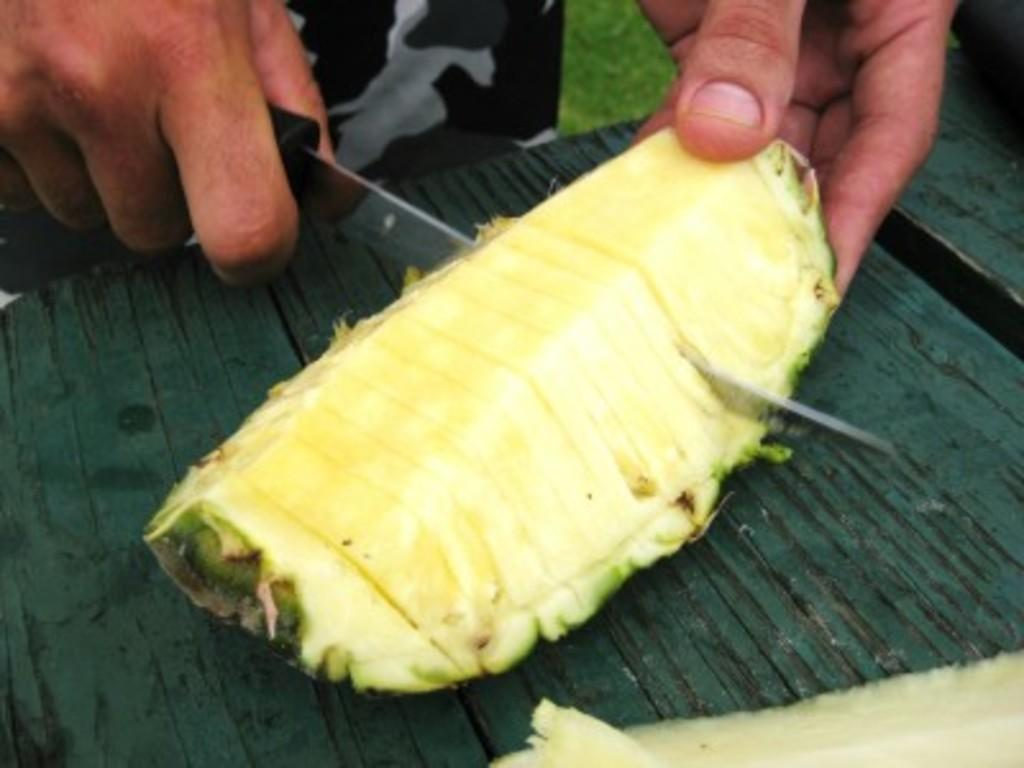What is the person in the image doing? The person is cutting a pineapple. What tool is the person using to cut the pineapple? The person is using a knife. What color is the surface on which the pineapple is being cut? The surface is green in color. What type of drum is being played on the table in the image? There is no drum or table present in the image; it only shows a person cutting a pineapple on a green surface. 